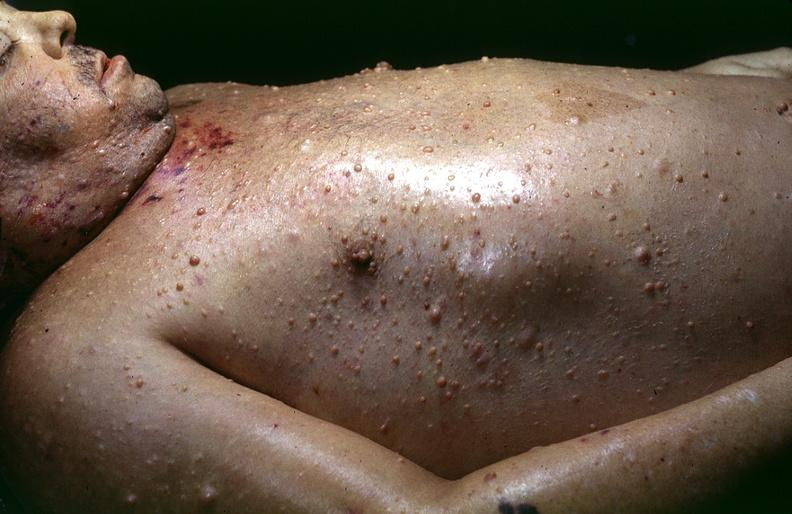what does this image show?
Answer the question using a single word or phrase. Skin 